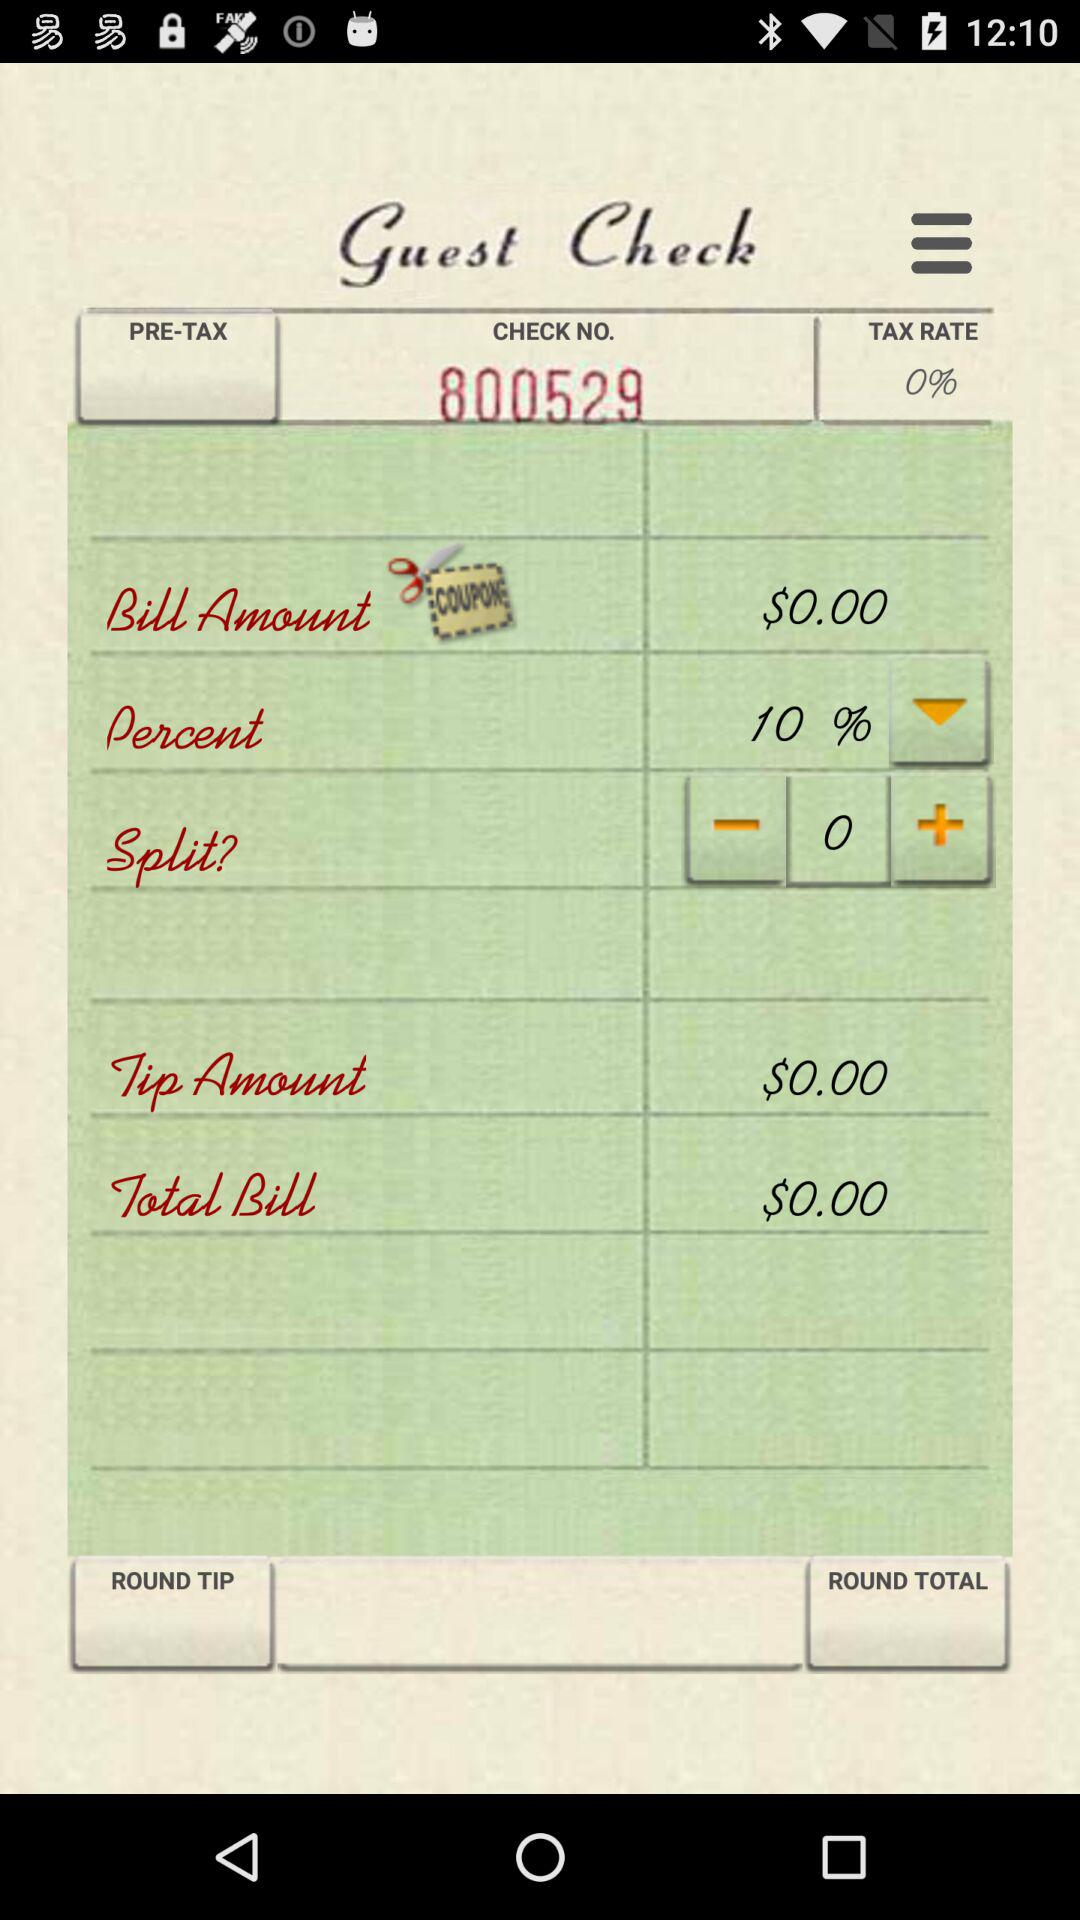What is the check no.? The check no. is 800529. 